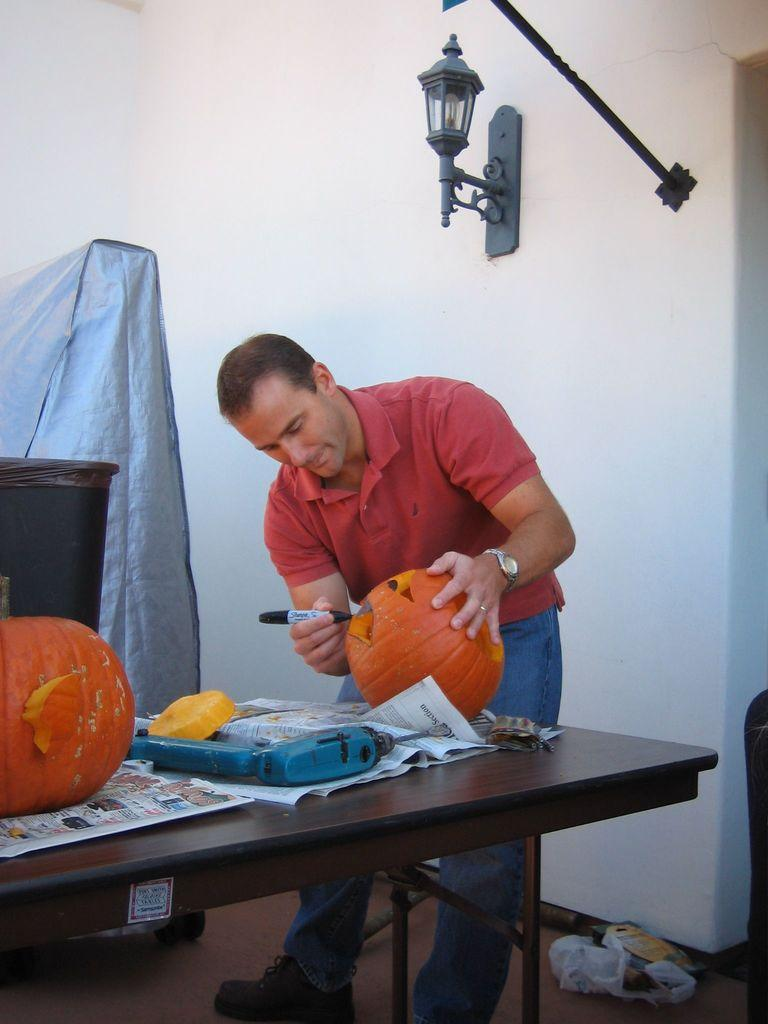What is the person in the image doing? The person is standing on the floor. What piece of furniture is in the image? There is a table in the image. What is on top of the table? A pumpkin is present on the table, along with other objects. What can be seen on the wall in the image? There is a wall in the image, but no specific details are provided about what is on it. What type of lighting is present in the image? There is a lamp in the image. What type of dock can be seen in the image? There is no dock present in the image. 